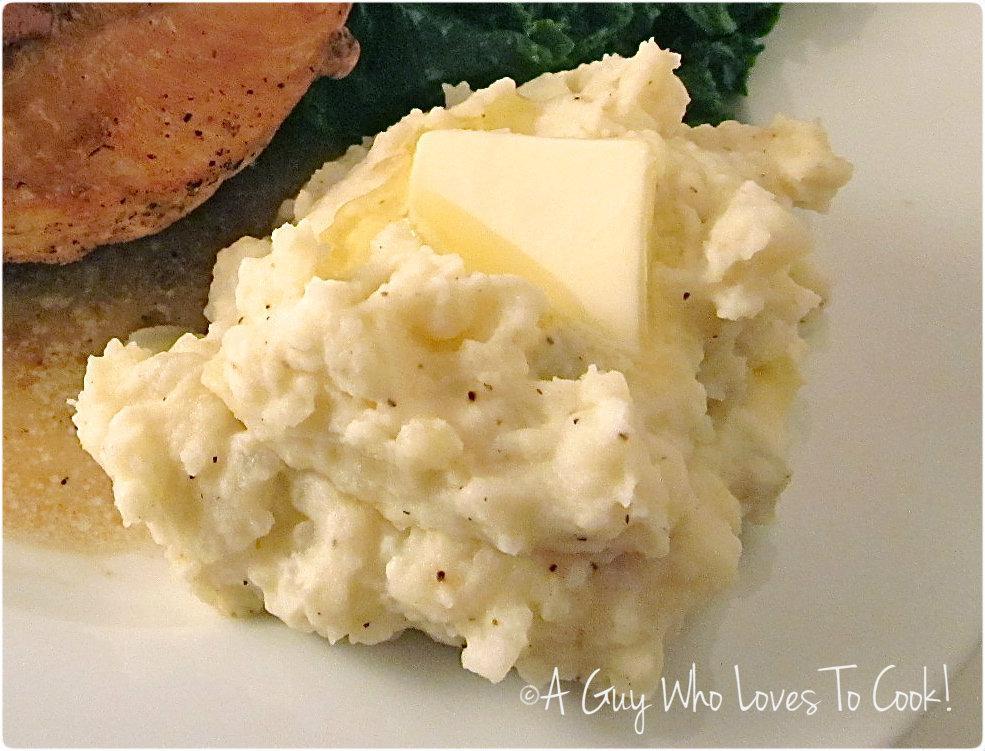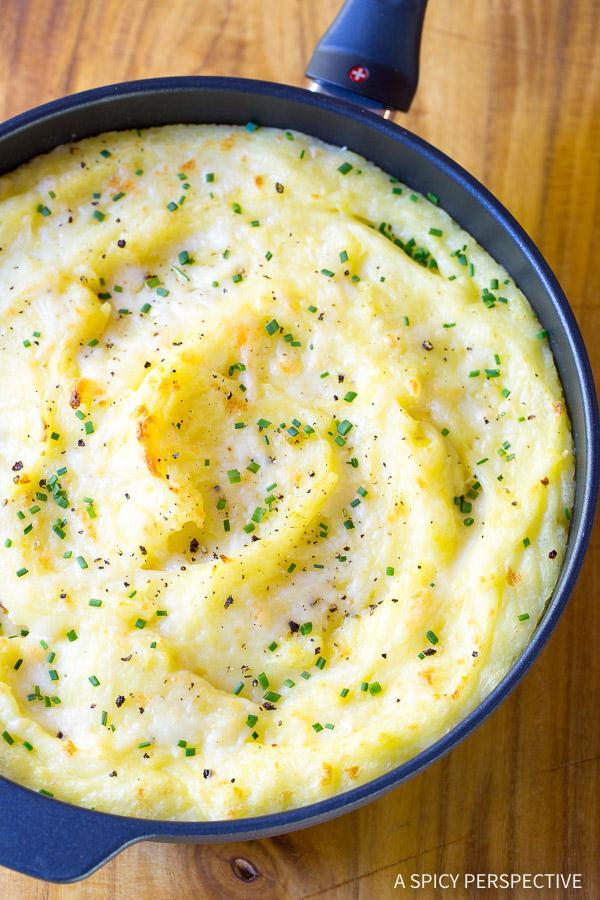The first image is the image on the left, the second image is the image on the right. Analyze the images presented: Is the assertion "One of the mashed potato dishes does not contain chives." valid? Answer yes or no. Yes. The first image is the image on the left, the second image is the image on the right. For the images shown, is this caption "The food in the image on the left is sitting in a brown plate." true? Answer yes or no. No. 